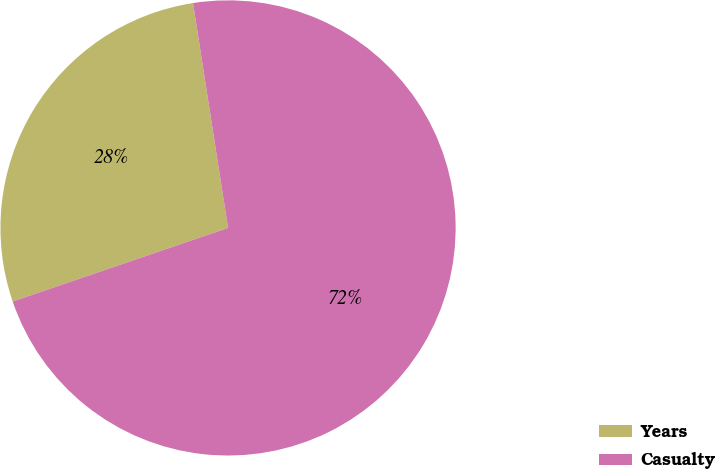Convert chart. <chart><loc_0><loc_0><loc_500><loc_500><pie_chart><fcel>Years<fcel>Casualty<nl><fcel>27.78%<fcel>72.22%<nl></chart> 